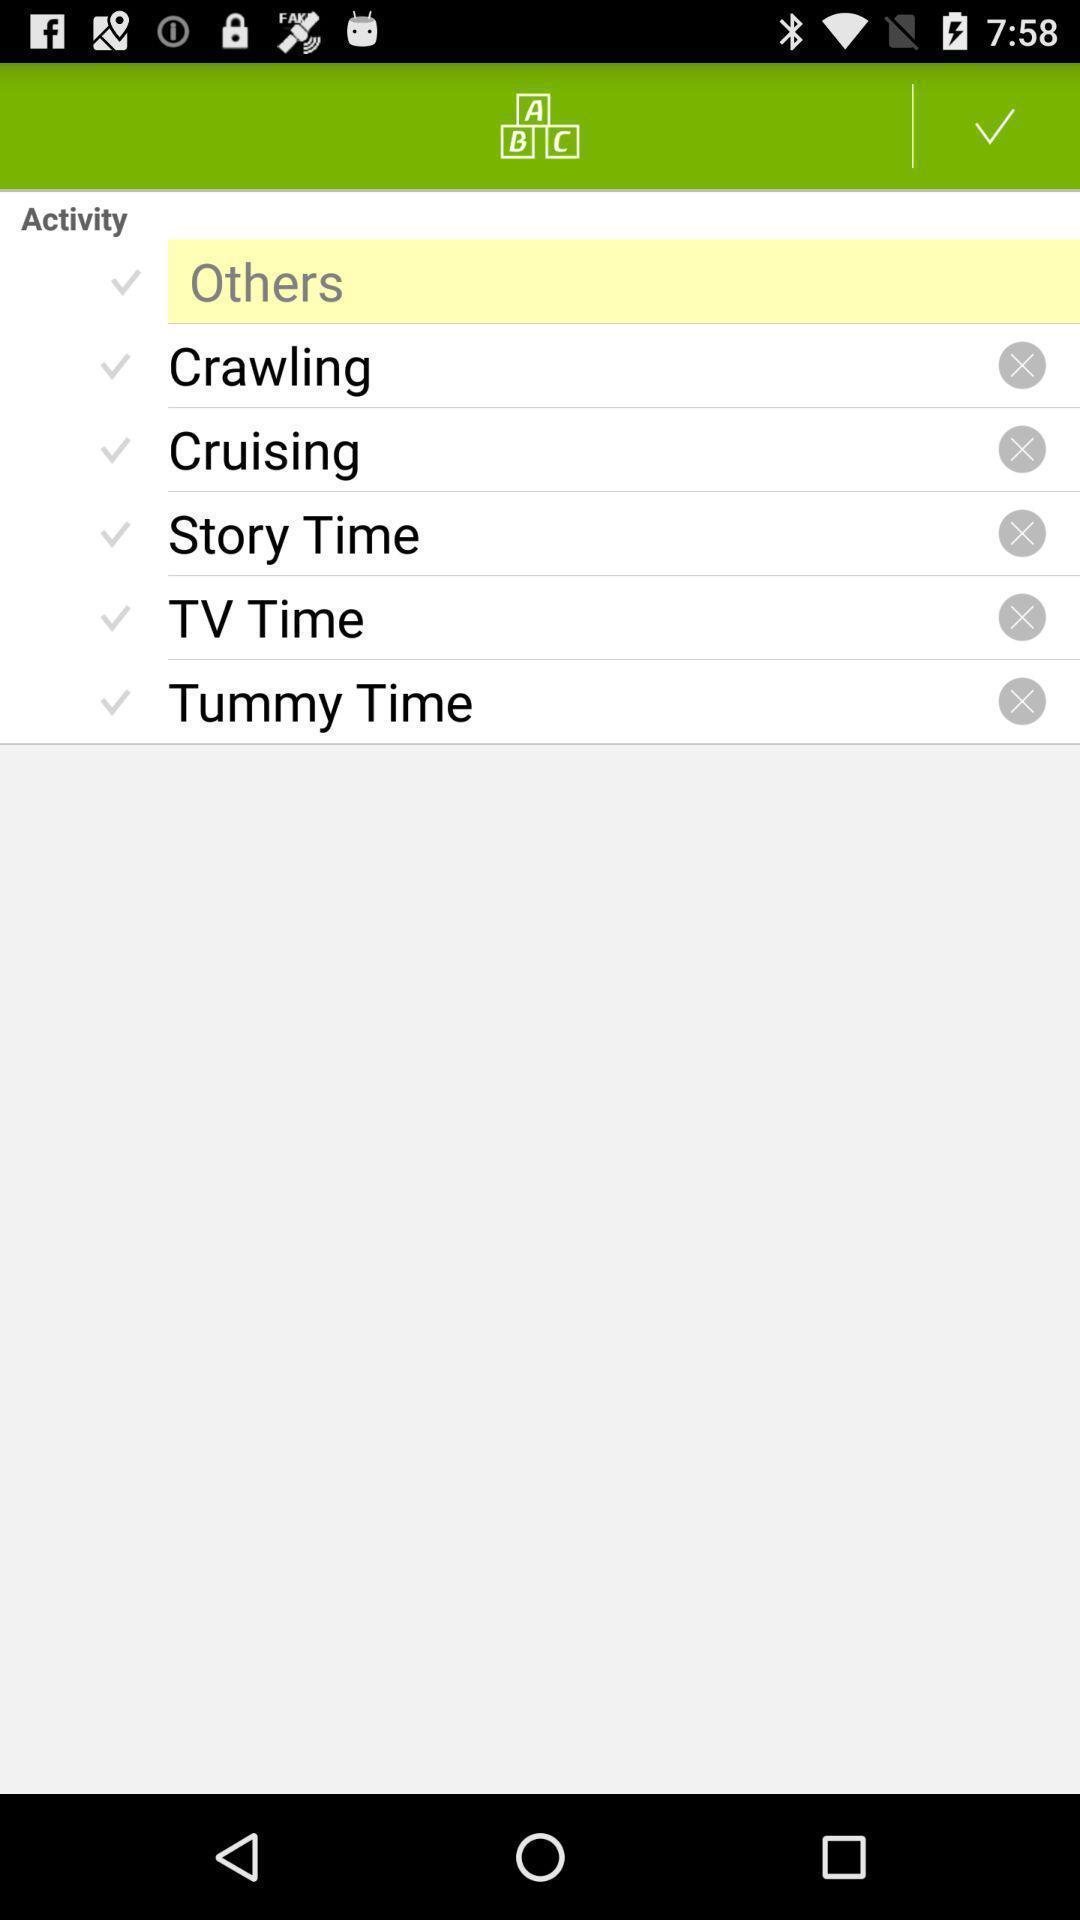Summarize the main components in this picture. Screen displaying a list of activity names. 